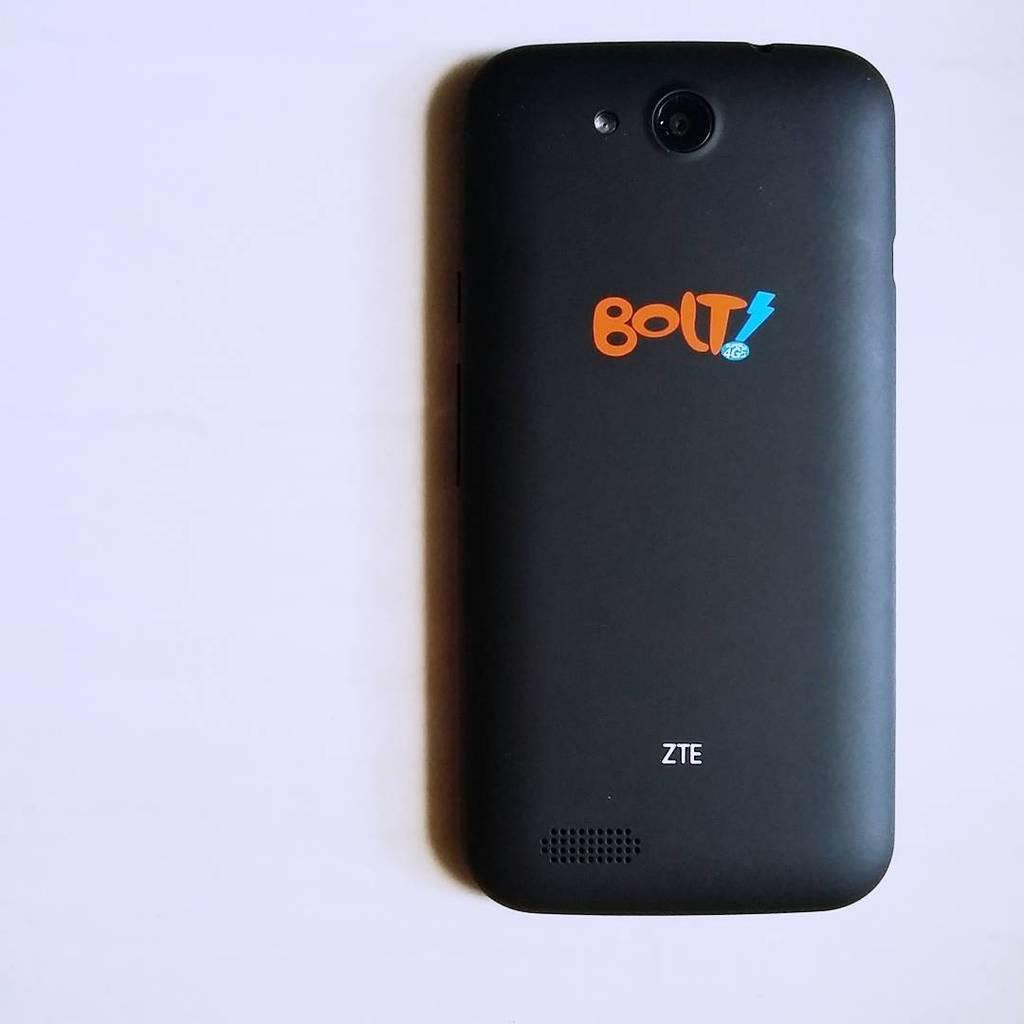<image>
Summarize the visual content of the image. The black smart phone was emblazoned with BOLT! 